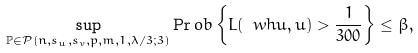<formula> <loc_0><loc_0><loc_500><loc_500>\sup _ { \mathbb { P } \in \mathcal { P } \left ( n , s _ { u } , s _ { v } , p , m , 1 , \lambda / 3 ; 3 \right ) } \Pr o b \left \{ L ( \ w h { u } , u ) > \frac { 1 } { 3 0 0 } \right \} \leq \beta ,</formula> 